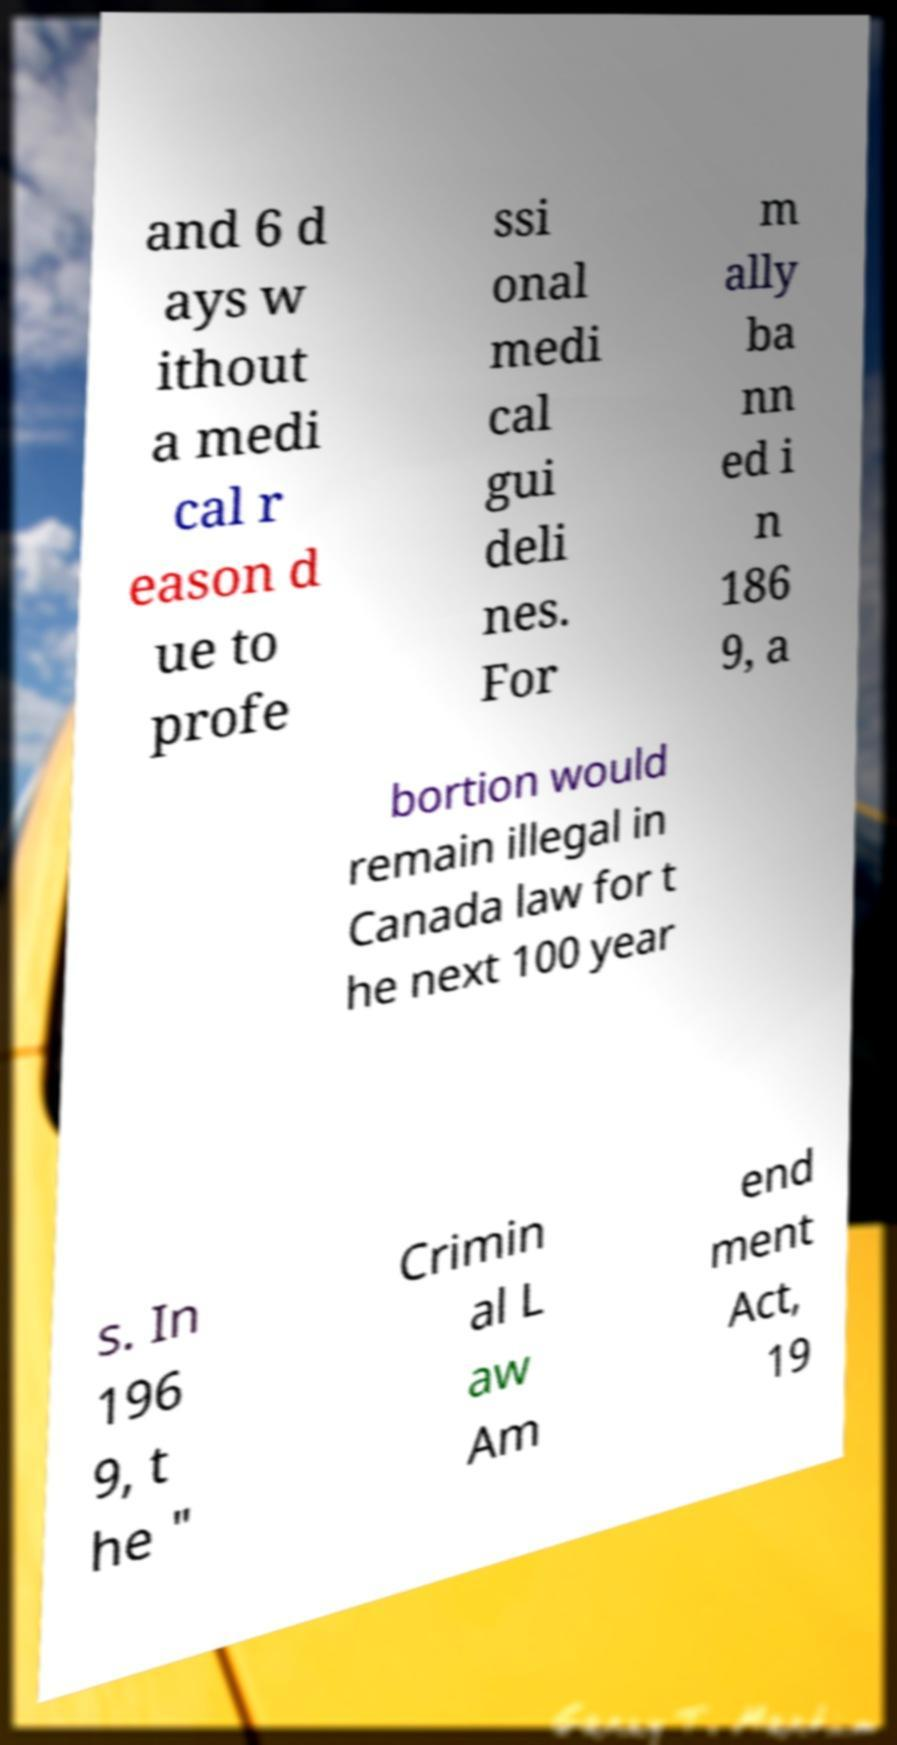For documentation purposes, I need the text within this image transcribed. Could you provide that? and 6 d ays w ithout a medi cal r eason d ue to profe ssi onal medi cal gui deli nes. For m ally ba nn ed i n 186 9, a bortion would remain illegal in Canada law for t he next 100 year s. In 196 9, t he " Crimin al L aw Am end ment Act, 19 